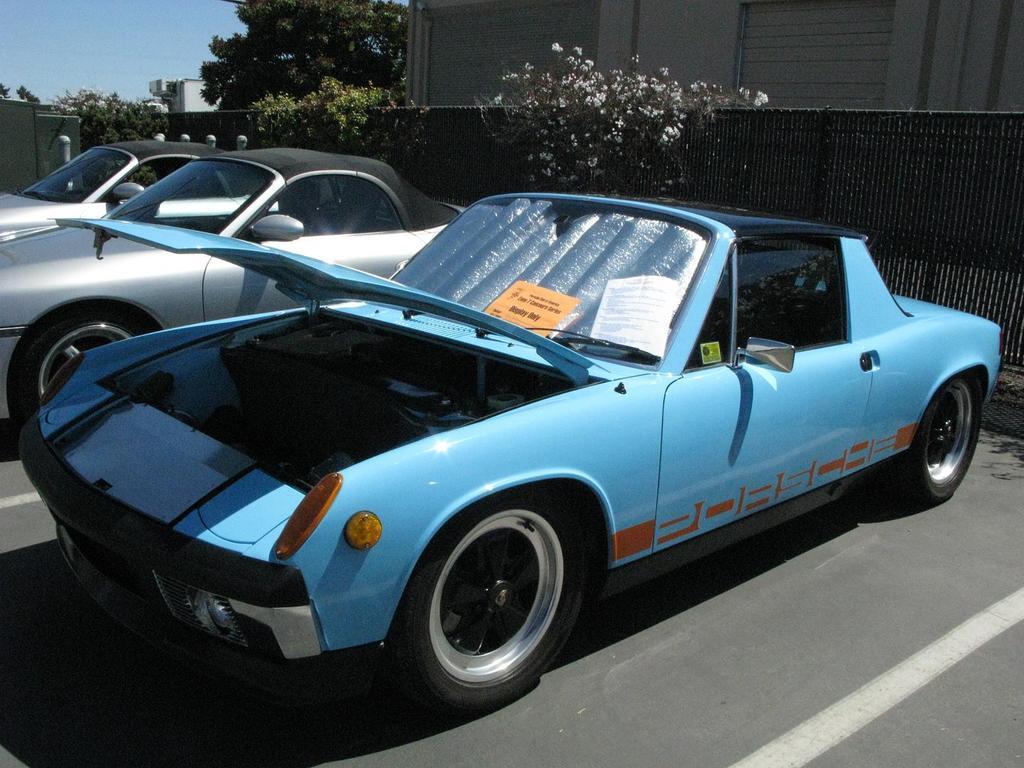Can you describe this image briefly? In the picture we can see three cars are parked near the wall and on the wall we can see some plants and behind the wall we can see a part of the building wall and beside it we can see a part of the tree and a part of the sky. 